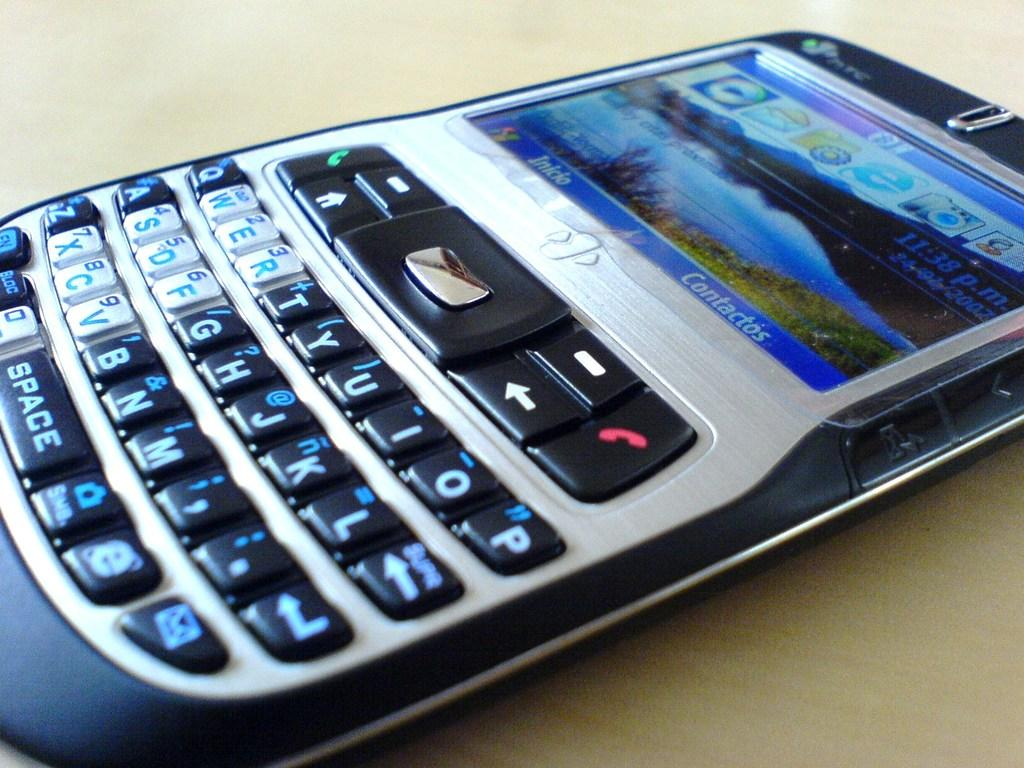<image>
Render a clear and concise summary of the photo. A phone screen has the word contactos on the screen. 